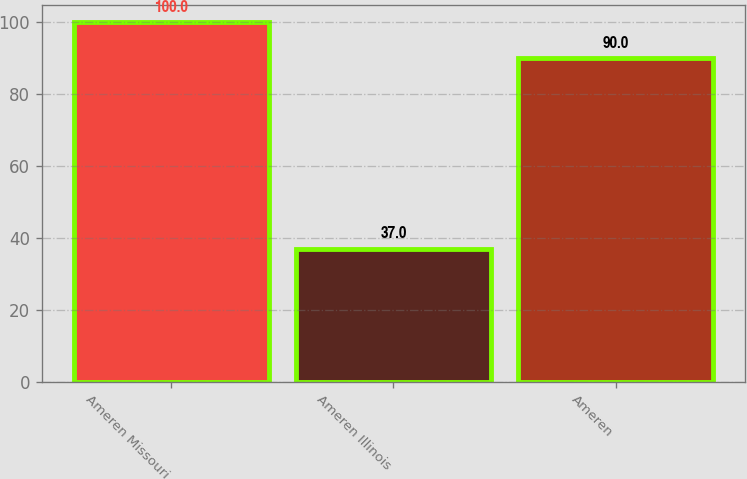<chart> <loc_0><loc_0><loc_500><loc_500><bar_chart><fcel>Ameren Missouri<fcel>Ameren Illinois<fcel>Ameren<nl><fcel>100<fcel>37<fcel>90<nl></chart> 